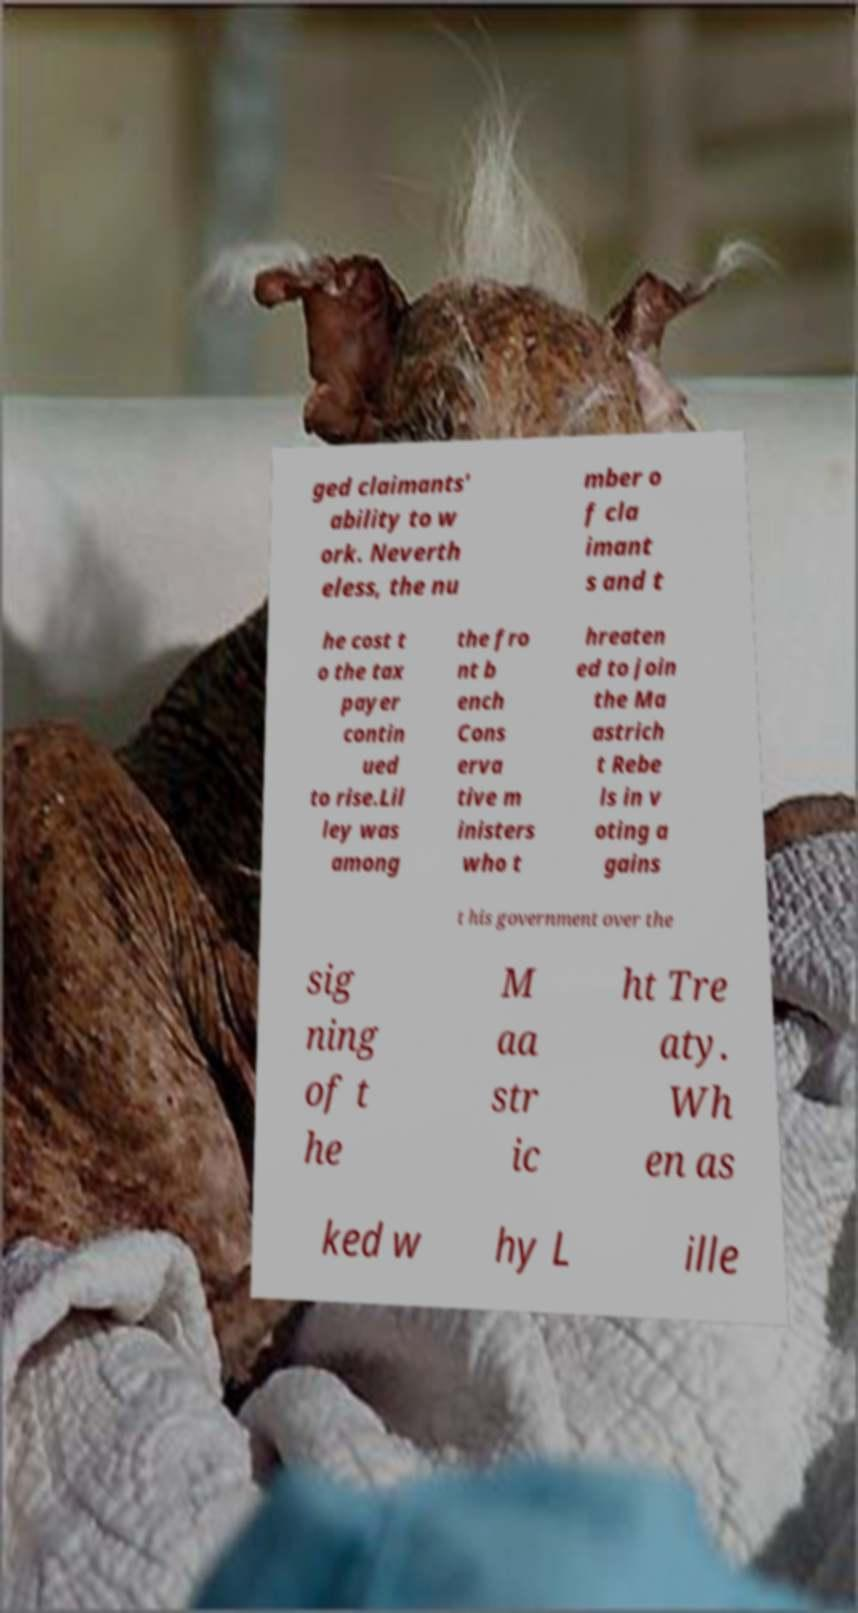What messages or text are displayed in this image? I need them in a readable, typed format. ged claimants' ability to w ork. Neverth eless, the nu mber o f cla imant s and t he cost t o the tax payer contin ued to rise.Lil ley was among the fro nt b ench Cons erva tive m inisters who t hreaten ed to join the Ma astrich t Rebe ls in v oting a gains t his government over the sig ning of t he M aa str ic ht Tre aty. Wh en as ked w hy L ille 